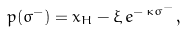<formula> <loc_0><loc_0><loc_500><loc_500>\, p ( \sigma ^ { - } ) = x _ { H } - \xi \, e ^ { - \, \kappa \sigma ^ { - } } \, , \,</formula> 